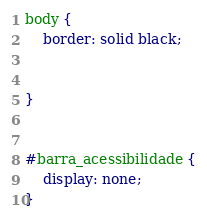Convert code to text. <code><loc_0><loc_0><loc_500><loc_500><_CSS_>body {
    border: solid black;
    
    
}


#barra_acessibilidade {
    display: none;
}



</code> 